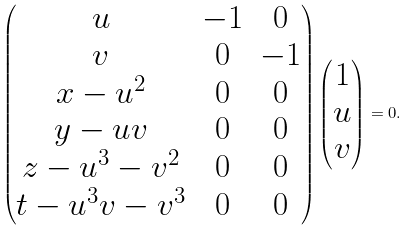Convert formula to latex. <formula><loc_0><loc_0><loc_500><loc_500>\begin{pmatrix} u & - 1 & 0 \\ v & 0 & - 1 \\ x - u ^ { 2 } & 0 & 0 \\ y - u v & 0 & 0 \\ z - u ^ { 3 } - v ^ { 2 } & 0 & 0 \\ t - u ^ { 3 } v - v ^ { 3 } & 0 & 0 \end{pmatrix} \begin{pmatrix} 1 \\ u \\ v \end{pmatrix} = 0 .</formula> 